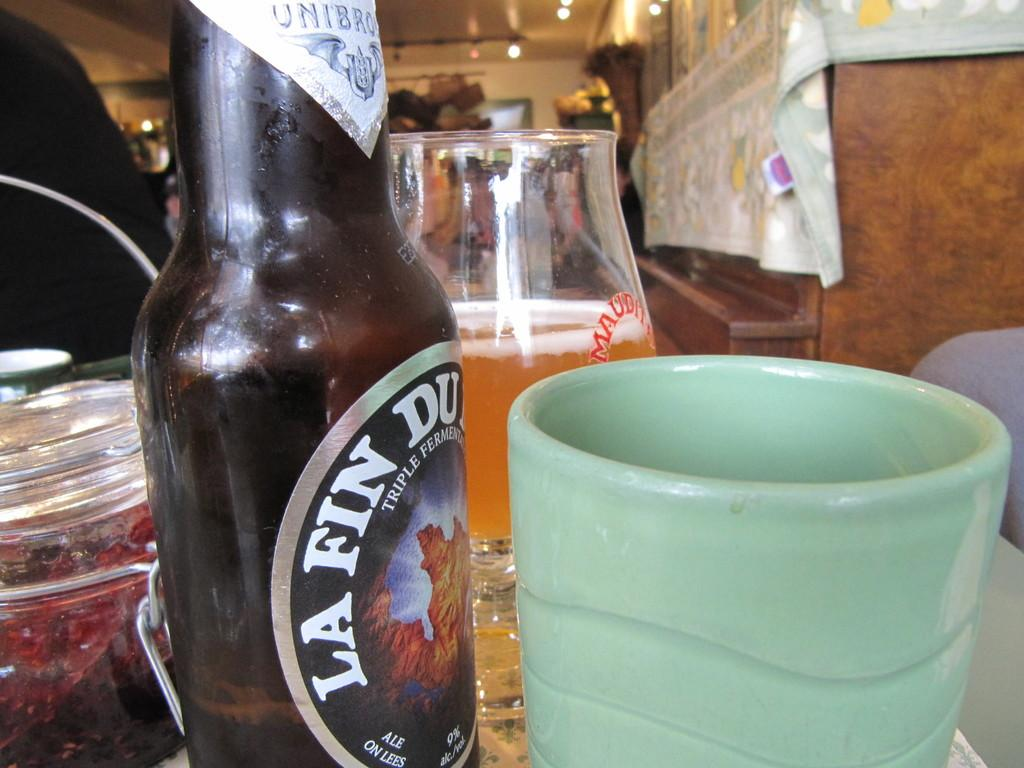What type of beverage container is present in the image? There is a wine bottle in the image. What other drinking vessel can be seen in the image? There is a glass in the image. Are there any additional drinking vessels in the image? Yes, there is a cup in the image. Where are the wine bottle, glass, and cup located in the image? The wine bottle, glass, and cup are placed on a table. What type of bag is being used to carry the wine bottle in the image? There is no bag present in the image; the wine bottle, glass, and cup are placed on a table. 